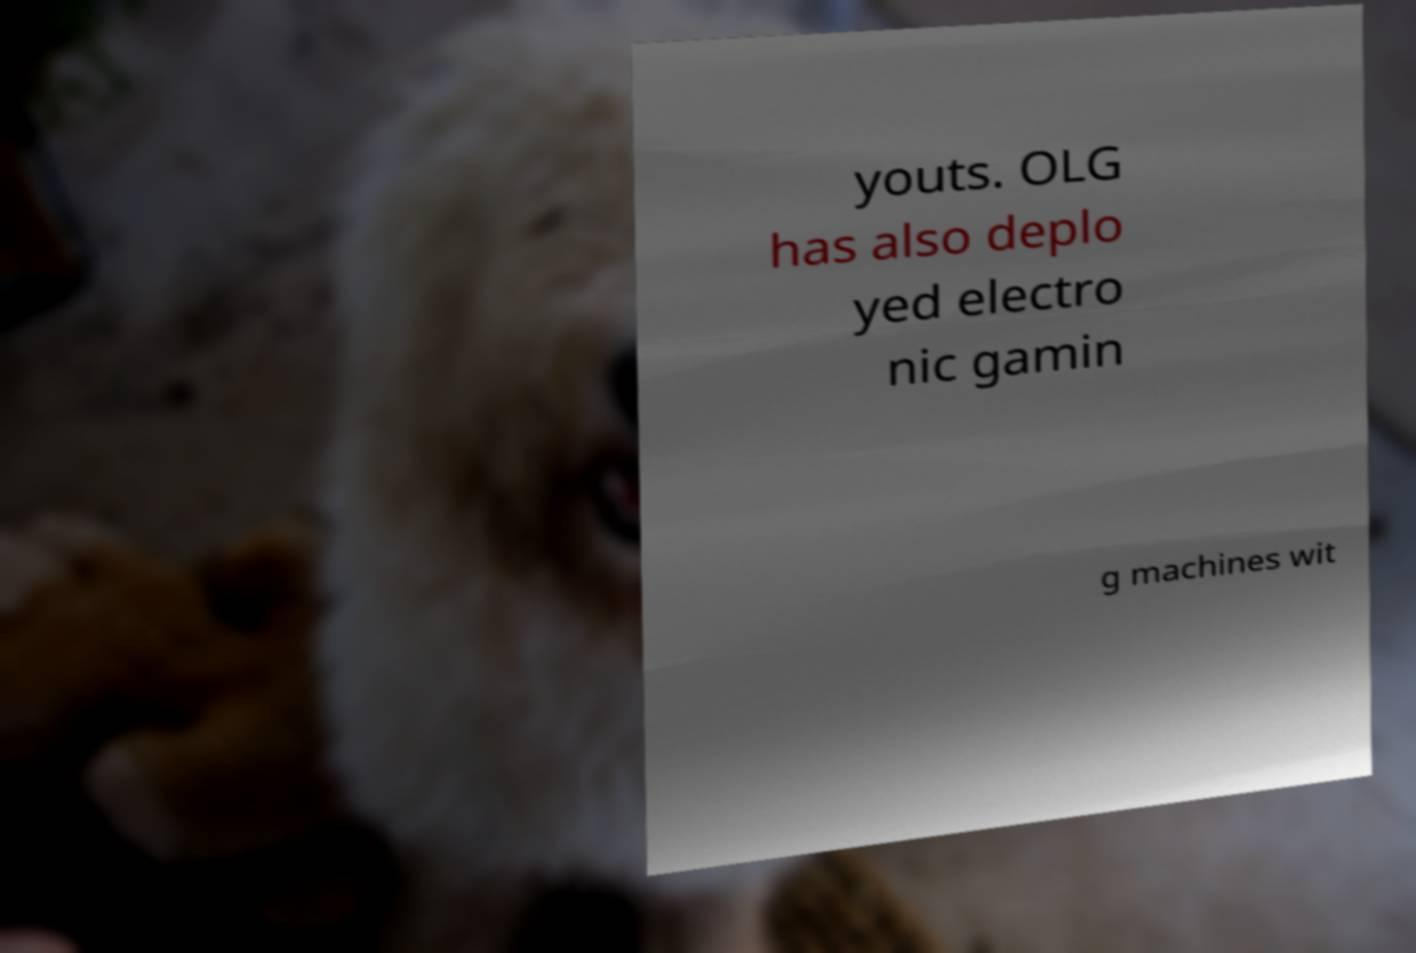Can you accurately transcribe the text from the provided image for me? youts. OLG has also deplo yed electro nic gamin g machines wit 